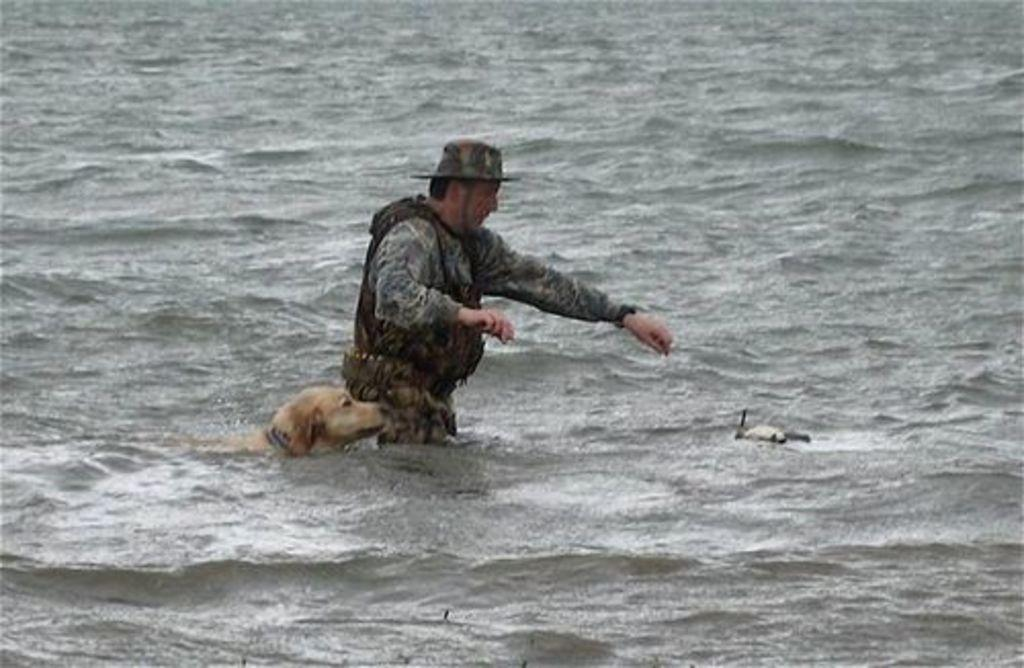Who or what is present in the image? There is a person and a dog in the image. Where are the person and the dog located? They are both in the water. Can you describe the setting of the image? The person and the dog are in the water, which suggests that the image might have been taken near a body of water such as a lake or a river. What type of wax can be seen melting on the seashore in the image? There is no wax or seashore present in the image; it features a person and a dog in the water. 